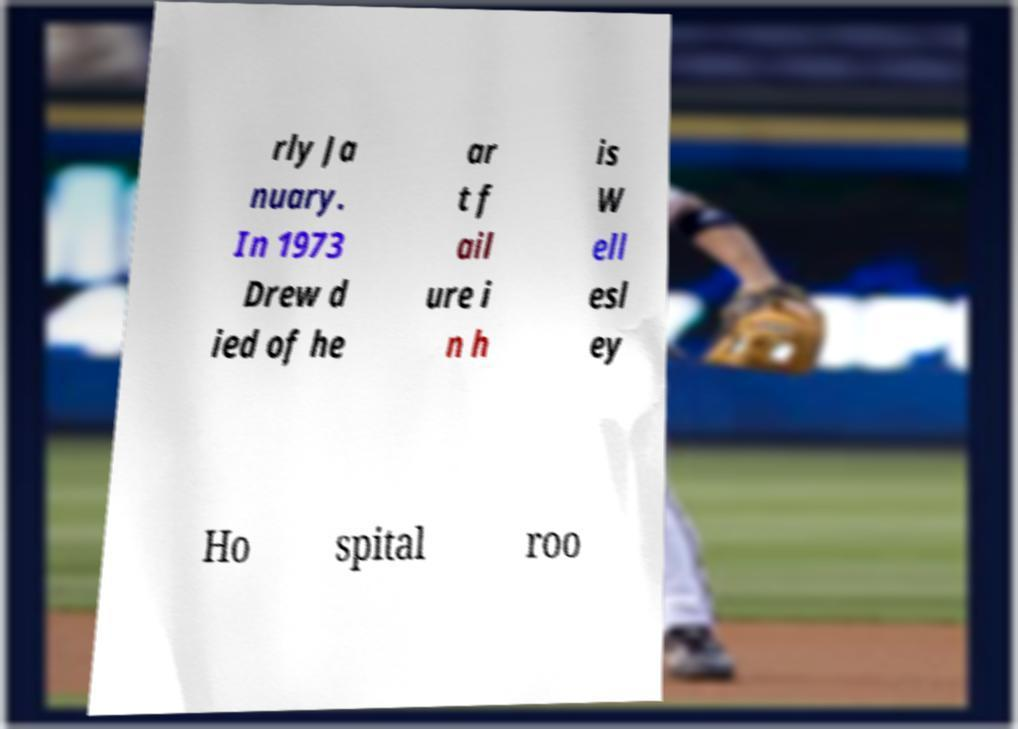There's text embedded in this image that I need extracted. Can you transcribe it verbatim? rly Ja nuary. In 1973 Drew d ied of he ar t f ail ure i n h is W ell esl ey Ho spital roo 